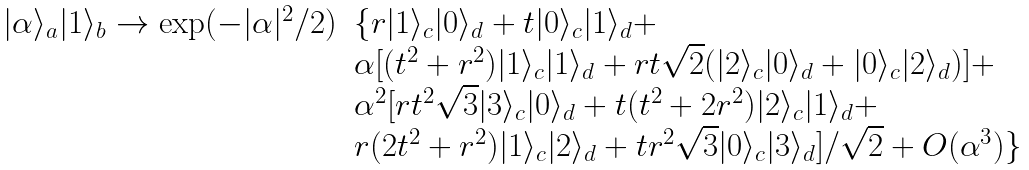Convert formula to latex. <formula><loc_0><loc_0><loc_500><loc_500>\begin{array} { r l } | \alpha \rangle _ { a } | 1 \rangle _ { b } \rightarrow \exp ( - | \alpha | ^ { 2 } / 2 ) & \{ r | 1 \rangle _ { c } | 0 \rangle _ { d } + t | 0 \rangle _ { c } | 1 \rangle _ { d } + \\ & \alpha [ ( t ^ { 2 } + r ^ { 2 } ) | 1 \rangle _ { c } | 1 \rangle _ { d } + r t \sqrt { 2 } ( | 2 \rangle _ { c } | 0 \rangle _ { d } + | 0 \rangle _ { c } | 2 \rangle _ { d } ) ] + \\ & \alpha ^ { 2 } [ r t ^ { 2 } \sqrt { 3 } | 3 \rangle _ { c } | 0 \rangle _ { d } + t ( t ^ { 2 } + 2 r ^ { 2 } ) | 2 \rangle _ { c } | 1 \rangle _ { d } + \\ & r ( 2 t ^ { 2 } + r ^ { 2 } ) | 1 \rangle _ { c } | 2 \rangle _ { d } + t r ^ { 2 } \sqrt { 3 } | 0 \rangle _ { c } | 3 \rangle _ { d } ] / \sqrt { 2 } + O ( \alpha ^ { 3 } ) \} \end{array}</formula> 